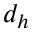<formula> <loc_0><loc_0><loc_500><loc_500>d _ { h }</formula> 